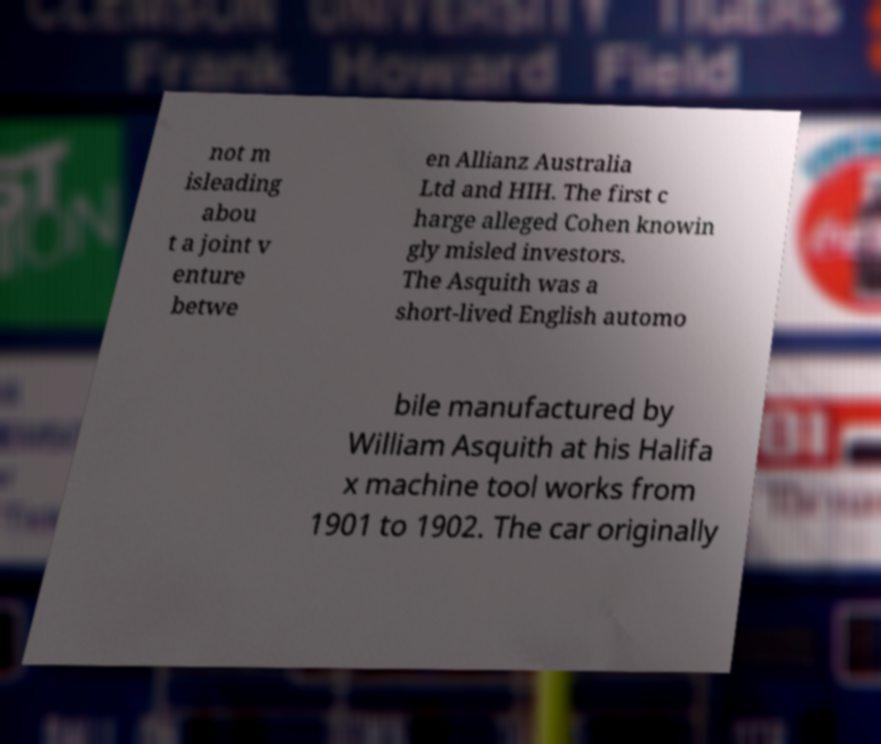There's text embedded in this image that I need extracted. Can you transcribe it verbatim? not m isleading abou t a joint v enture betwe en Allianz Australia Ltd and HIH. The first c harge alleged Cohen knowin gly misled investors. The Asquith was a short-lived English automo bile manufactured by William Asquith at his Halifa x machine tool works from 1901 to 1902. The car originally 